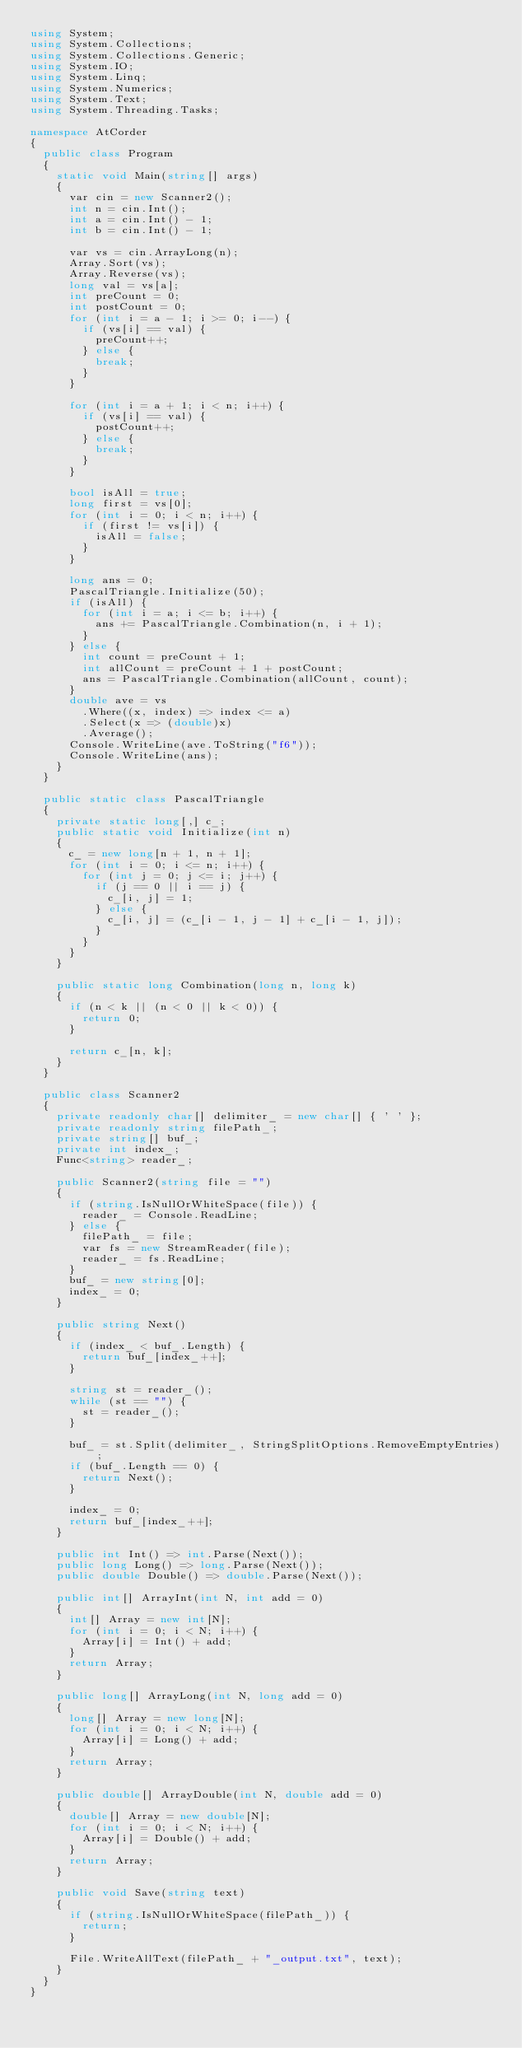Convert code to text. <code><loc_0><loc_0><loc_500><loc_500><_C#_>using System;
using System.Collections;
using System.Collections.Generic;
using System.IO;
using System.Linq;
using System.Numerics;
using System.Text;
using System.Threading.Tasks;

namespace AtCorder
{
	public class Program
	{
		static void Main(string[] args)
		{
			var cin = new Scanner2();
			int n = cin.Int();
			int a = cin.Int() - 1;
			int b = cin.Int() - 1;

			var vs = cin.ArrayLong(n);
			Array.Sort(vs);
			Array.Reverse(vs);
			long val = vs[a];
			int preCount = 0;
			int postCount = 0;
			for (int i = a - 1; i >= 0; i--) {
				if (vs[i] == val) {
					preCount++;
				} else {
					break;
				}
			}

			for (int i = a + 1; i < n; i++) {
				if (vs[i] == val) {
					postCount++;
				} else {
					break;
				}
			}

			bool isAll = true;
			long first = vs[0];
			for (int i = 0; i < n; i++) {
				if (first != vs[i]) {
					isAll = false;
				}
			}
			
			long ans = 0;
			PascalTriangle.Initialize(50);
			if (isAll) {
				for (int i = a; i <= b; i++) {
					ans += PascalTriangle.Combination(n, i + 1);
				}
			} else {
				int count = preCount + 1;
				int allCount = preCount + 1 + postCount;
				ans = PascalTriangle.Combination(allCount, count);
			}
			double ave = vs
				.Where((x, index) => index <= a)
				.Select(x => (double)x)
				.Average();
			Console.WriteLine(ave.ToString("f6"));
			Console.WriteLine(ans);
		}
	}

	public static class PascalTriangle
	{
		private static long[,] c_;
		public static void Initialize(int n)
		{
			c_ = new long[n + 1, n + 1];
			for (int i = 0; i <= n; i++) {
				for (int j = 0; j <= i; j++) {
					if (j == 0 || i == j) {
						c_[i, j] = 1;
					} else {
						c_[i, j] = (c_[i - 1, j - 1] + c_[i - 1, j]);
					}
				}
			}
		}

		public static long Combination(long n, long k)
		{
			if (n < k || (n < 0 || k < 0)) {
				return 0;
			}

			return c_[n, k];
		}
	}

	public class Scanner2
	{
		private readonly char[] delimiter_ = new char[] { ' ' };
		private readonly string filePath_;
		private string[] buf_;
		private int index_;
		Func<string> reader_;

		public Scanner2(string file = "")
		{
			if (string.IsNullOrWhiteSpace(file)) {
				reader_ = Console.ReadLine;
			} else {
				filePath_ = file;
				var fs = new StreamReader(file);
				reader_ = fs.ReadLine;
			}
			buf_ = new string[0];
			index_ = 0;
		}

		public string Next()
		{
			if (index_ < buf_.Length) {
				return buf_[index_++];
			}

			string st = reader_();
			while (st == "") {
				st = reader_();
			}

			buf_ = st.Split(delimiter_, StringSplitOptions.RemoveEmptyEntries);
			if (buf_.Length == 0) {
				return Next();
			}

			index_ = 0;
			return buf_[index_++];
		}

		public int Int() => int.Parse(Next());
		public long Long() => long.Parse(Next());
		public double Double() => double.Parse(Next());

		public int[] ArrayInt(int N, int add = 0)
		{
			int[] Array = new int[N];
			for (int i = 0; i < N; i++) {
				Array[i] = Int() + add;
			}
			return Array;
		}

		public long[] ArrayLong(int N, long add = 0)
		{
			long[] Array = new long[N];
			for (int i = 0; i < N; i++) {
				Array[i] = Long() + add;
			}
			return Array;
		}

		public double[] ArrayDouble(int N, double add = 0)
		{
			double[] Array = new double[N];
			for (int i = 0; i < N; i++) {
				Array[i] = Double() + add;
			}
			return Array;
		}

		public void Save(string text)
		{
			if (string.IsNullOrWhiteSpace(filePath_)) {
				return;
			}

			File.WriteAllText(filePath_ + "_output.txt", text);
		}
	}
}</code> 